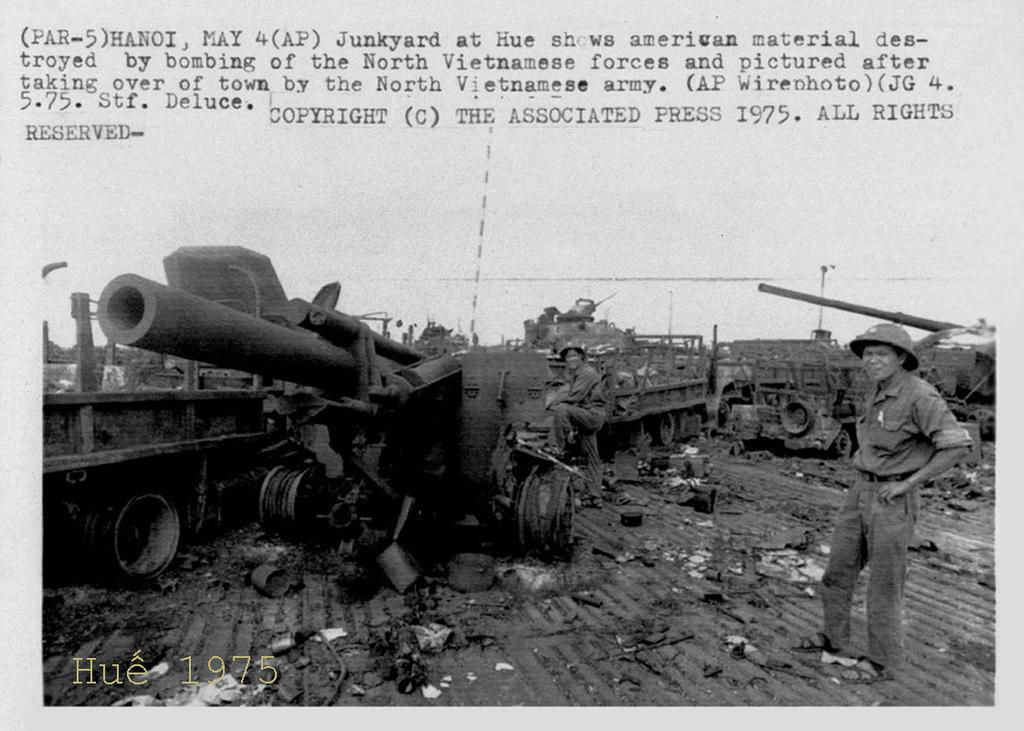What is the copyright date?
Give a very brief answer. 1975. What is this a picture of?
Make the answer very short. Junkyard at hue. 